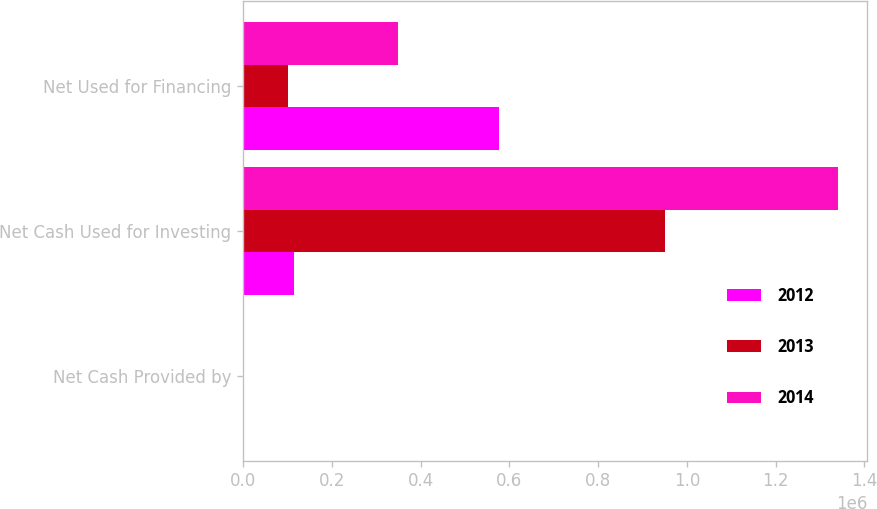Convert chart to OTSL. <chart><loc_0><loc_0><loc_500><loc_500><stacked_bar_chart><ecel><fcel>Net Cash Provided by<fcel>Net Cash Used for Investing<fcel>Net Used for Financing<nl><fcel>2012<fcel>30.4<fcel>114751<fcel>576610<nl><fcel>2013<fcel>34.6<fcel>949926<fcel>100557<nl><fcel>2014<fcel>30.2<fcel>1.33969e+06<fcel>349627<nl></chart> 